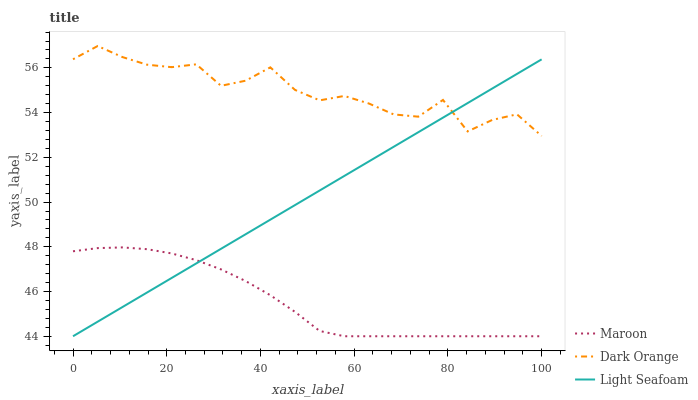Does Light Seafoam have the minimum area under the curve?
Answer yes or no. No. Does Light Seafoam have the maximum area under the curve?
Answer yes or no. No. Is Maroon the smoothest?
Answer yes or no. No. Is Maroon the roughest?
Answer yes or no. No. Does Light Seafoam have the highest value?
Answer yes or no. No. Is Maroon less than Dark Orange?
Answer yes or no. Yes. Is Dark Orange greater than Maroon?
Answer yes or no. Yes. Does Maroon intersect Dark Orange?
Answer yes or no. No. 